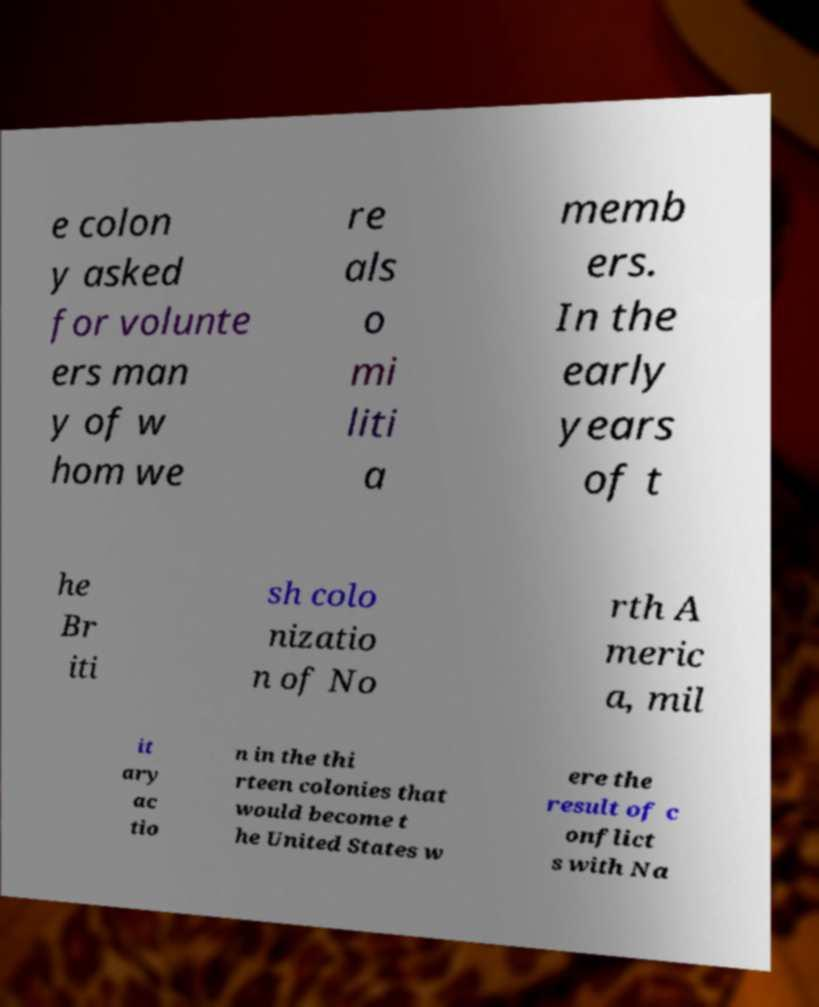Can you read and provide the text displayed in the image?This photo seems to have some interesting text. Can you extract and type it out for me? e colon y asked for volunte ers man y of w hom we re als o mi liti a memb ers. In the early years of t he Br iti sh colo nizatio n of No rth A meric a, mil it ary ac tio n in the thi rteen colonies that would become t he United States w ere the result of c onflict s with Na 